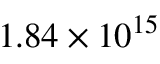<formula> <loc_0><loc_0><loc_500><loc_500>1 . 8 4 \times 1 0 ^ { 1 5 }</formula> 